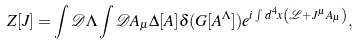<formula> <loc_0><loc_0><loc_500><loc_500>Z [ J ] = \int \mathcal { D } \Lambda \int \mathcal { D } A _ { \mu } \Delta [ A ] \delta ( G [ A ^ { \Lambda } ] ) e ^ { i \int \, d ^ { 4 } x \left ( \mathcal { L } + J ^ { \mu } A _ { \mu } \right ) } ,</formula> 